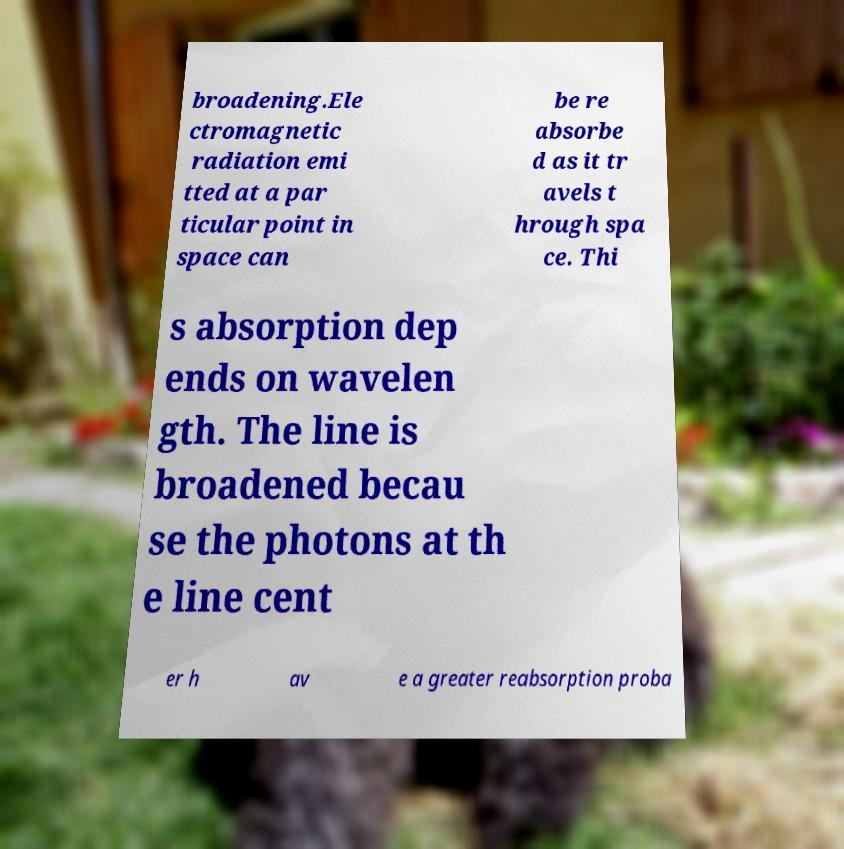I need the written content from this picture converted into text. Can you do that? broadening.Ele ctromagnetic radiation emi tted at a par ticular point in space can be re absorbe d as it tr avels t hrough spa ce. Thi s absorption dep ends on wavelen gth. The line is broadened becau se the photons at th e line cent er h av e a greater reabsorption proba 